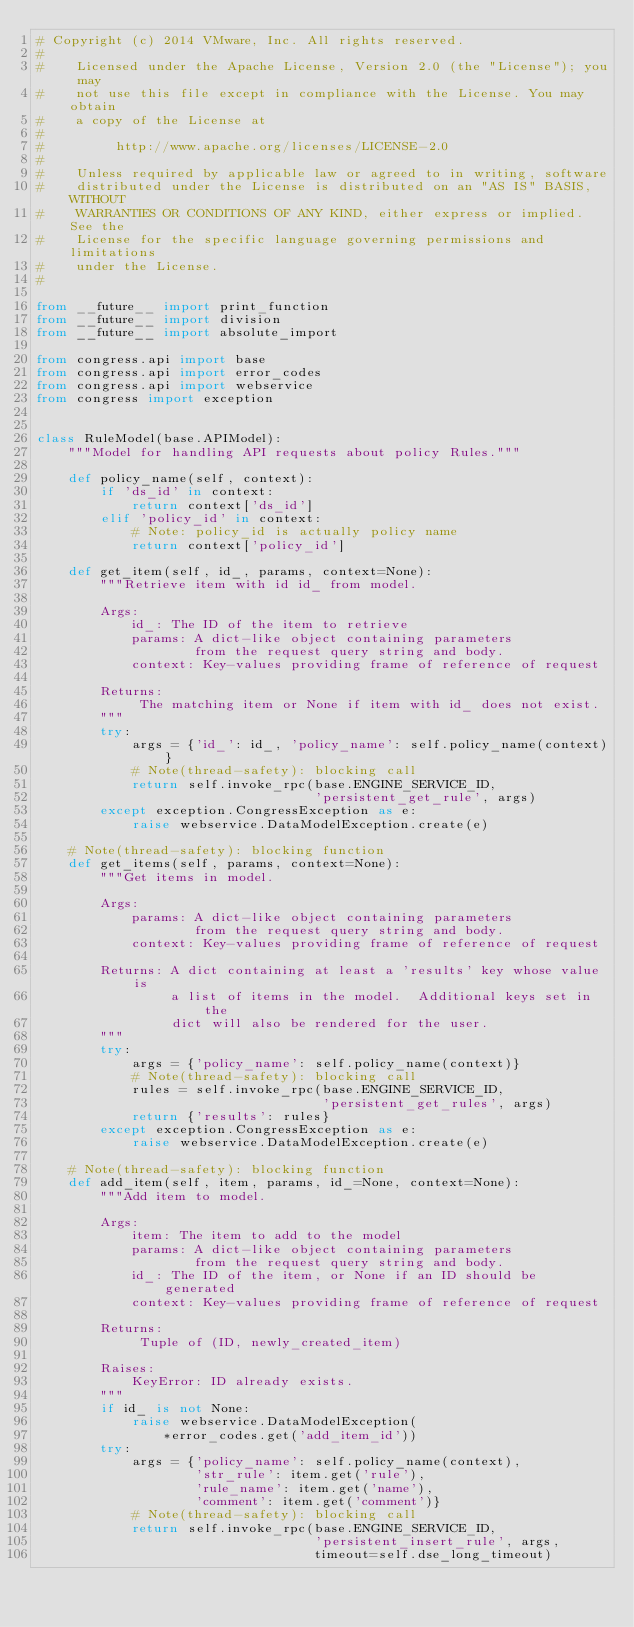Convert code to text. <code><loc_0><loc_0><loc_500><loc_500><_Python_># Copyright (c) 2014 VMware, Inc. All rights reserved.
#
#    Licensed under the Apache License, Version 2.0 (the "License"); you may
#    not use this file except in compliance with the License. You may obtain
#    a copy of the License at
#
#         http://www.apache.org/licenses/LICENSE-2.0
#
#    Unless required by applicable law or agreed to in writing, software
#    distributed under the License is distributed on an "AS IS" BASIS, WITHOUT
#    WARRANTIES OR CONDITIONS OF ANY KIND, either express or implied. See the
#    License for the specific language governing permissions and limitations
#    under the License.
#

from __future__ import print_function
from __future__ import division
from __future__ import absolute_import

from congress.api import base
from congress.api import error_codes
from congress.api import webservice
from congress import exception


class RuleModel(base.APIModel):
    """Model for handling API requests about policy Rules."""

    def policy_name(self, context):
        if 'ds_id' in context:
            return context['ds_id']
        elif 'policy_id' in context:
            # Note: policy_id is actually policy name
            return context['policy_id']

    def get_item(self, id_, params, context=None):
        """Retrieve item with id id_ from model.

        Args:
            id_: The ID of the item to retrieve
            params: A dict-like object containing parameters
                    from the request query string and body.
            context: Key-values providing frame of reference of request

        Returns:
             The matching item or None if item with id_ does not exist.
        """
        try:
            args = {'id_': id_, 'policy_name': self.policy_name(context)}
            # Note(thread-safety): blocking call
            return self.invoke_rpc(base.ENGINE_SERVICE_ID,
                                   'persistent_get_rule', args)
        except exception.CongressException as e:
            raise webservice.DataModelException.create(e)

    # Note(thread-safety): blocking function
    def get_items(self, params, context=None):
        """Get items in model.

        Args:
            params: A dict-like object containing parameters
                    from the request query string and body.
            context: Key-values providing frame of reference of request

        Returns: A dict containing at least a 'results' key whose value is
                 a list of items in the model.  Additional keys set in the
                 dict will also be rendered for the user.
        """
        try:
            args = {'policy_name': self.policy_name(context)}
            # Note(thread-safety): blocking call
            rules = self.invoke_rpc(base.ENGINE_SERVICE_ID,
                                    'persistent_get_rules', args)
            return {'results': rules}
        except exception.CongressException as e:
            raise webservice.DataModelException.create(e)

    # Note(thread-safety): blocking function
    def add_item(self, item, params, id_=None, context=None):
        """Add item to model.

        Args:
            item: The item to add to the model
            params: A dict-like object containing parameters
                    from the request query string and body.
            id_: The ID of the item, or None if an ID should be generated
            context: Key-values providing frame of reference of request

        Returns:
             Tuple of (ID, newly_created_item)

        Raises:
            KeyError: ID already exists.
        """
        if id_ is not None:
            raise webservice.DataModelException(
                *error_codes.get('add_item_id'))
        try:
            args = {'policy_name': self.policy_name(context),
                    'str_rule': item.get('rule'),
                    'rule_name': item.get('name'),
                    'comment': item.get('comment')}
            # Note(thread-safety): blocking call
            return self.invoke_rpc(base.ENGINE_SERVICE_ID,
                                   'persistent_insert_rule', args,
                                   timeout=self.dse_long_timeout)</code> 